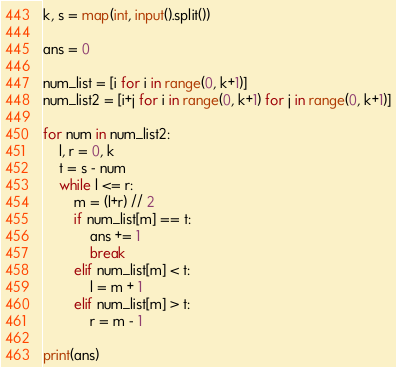<code> <loc_0><loc_0><loc_500><loc_500><_Python_>k, s = map(int, input().split())

ans = 0

num_list = [i for i in range(0, k+1)]
num_list2 = [i+j for i in range(0, k+1) for j in range(0, k+1)]

for num in num_list2:
    l, r = 0, k
    t = s - num
    while l <= r:
        m = (l+r) // 2
        if num_list[m] == t:
            ans += 1
            break
        elif num_list[m] < t:
            l = m + 1
        elif num_list[m] > t:
            r = m - 1

print(ans)
</code> 